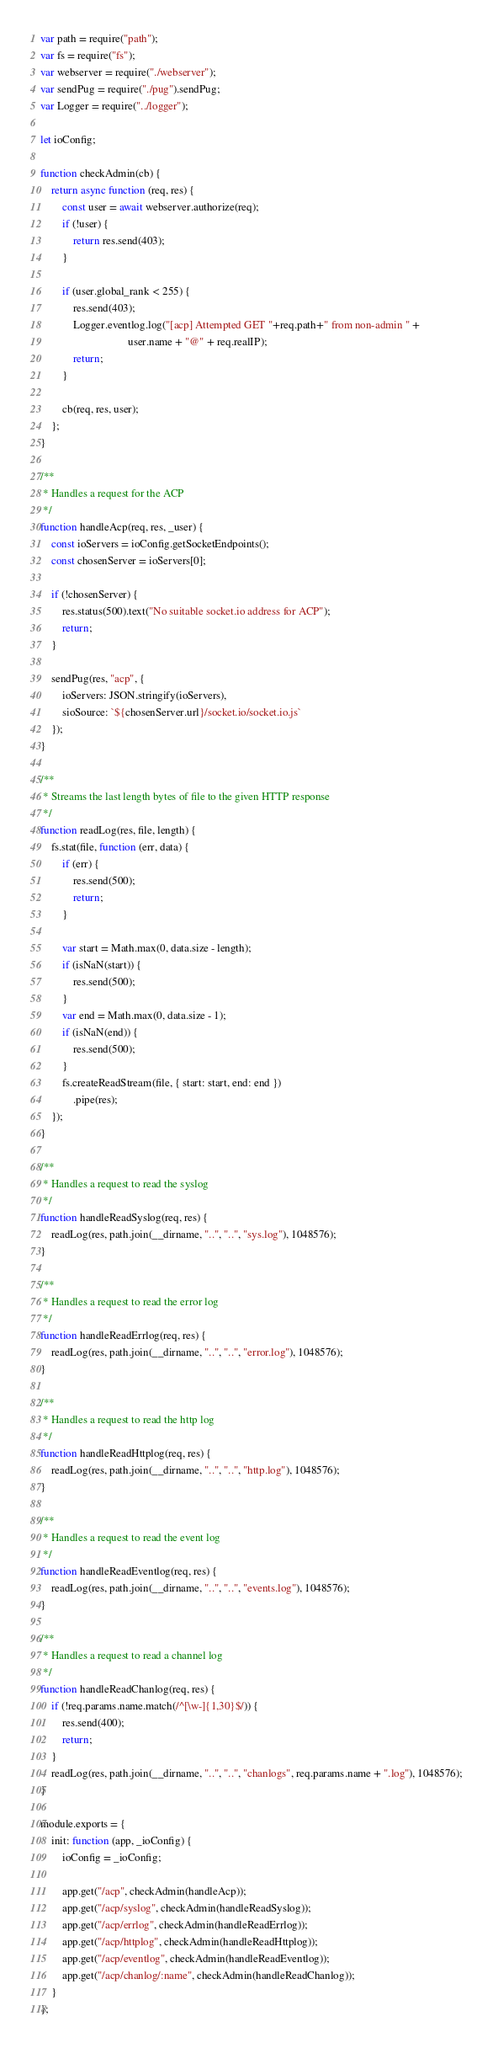<code> <loc_0><loc_0><loc_500><loc_500><_JavaScript_>var path = require("path");
var fs = require("fs");
var webserver = require("./webserver");
var sendPug = require("./pug").sendPug;
var Logger = require("../logger");

let ioConfig;

function checkAdmin(cb) {
    return async function (req, res) {
        const user = await webserver.authorize(req);
        if (!user) {
            return res.send(403);
        }

        if (user.global_rank < 255) {
            res.send(403);
            Logger.eventlog.log("[acp] Attempted GET "+req.path+" from non-admin " +
                                user.name + "@" + req.realIP);
            return;
        }

        cb(req, res, user);
    };
}

/**
 * Handles a request for the ACP
 */
function handleAcp(req, res, _user) {
    const ioServers = ioConfig.getSocketEndpoints();
    const chosenServer = ioServers[0];

    if (!chosenServer) {
        res.status(500).text("No suitable socket.io address for ACP");
        return;
    }

    sendPug(res, "acp", {
        ioServers: JSON.stringify(ioServers),
        sioSource: `${chosenServer.url}/socket.io/socket.io.js`
    });
}

/**
 * Streams the last length bytes of file to the given HTTP response
 */
function readLog(res, file, length) {
    fs.stat(file, function (err, data) {
        if (err) {
            res.send(500);
            return;
        }

        var start = Math.max(0, data.size - length);
        if (isNaN(start)) {
            res.send(500);
        }
        var end = Math.max(0, data.size - 1);
        if (isNaN(end)) {
            res.send(500);
        }
        fs.createReadStream(file, { start: start, end: end })
            .pipe(res);
    });
}

/**
 * Handles a request to read the syslog
 */
function handleReadSyslog(req, res) {
    readLog(res, path.join(__dirname, "..", "..", "sys.log"), 1048576);
}

/**
 * Handles a request to read the error log
 */
function handleReadErrlog(req, res) {
    readLog(res, path.join(__dirname, "..", "..", "error.log"), 1048576);
}

/**
 * Handles a request to read the http log
 */
function handleReadHttplog(req, res) {
    readLog(res, path.join(__dirname, "..", "..", "http.log"), 1048576);
}

/**
 * Handles a request to read the event log
 */
function handleReadEventlog(req, res) {
    readLog(res, path.join(__dirname, "..", "..", "events.log"), 1048576);
}

/**
 * Handles a request to read a channel log
 */
function handleReadChanlog(req, res) {
    if (!req.params.name.match(/^[\w-]{1,30}$/)) {
        res.send(400);
        return;
    }
    readLog(res, path.join(__dirname, "..", "..", "chanlogs", req.params.name + ".log"), 1048576);
}

module.exports = {
    init: function (app, _ioConfig) {
        ioConfig = _ioConfig;

        app.get("/acp", checkAdmin(handleAcp));
        app.get("/acp/syslog", checkAdmin(handleReadSyslog));
        app.get("/acp/errlog", checkAdmin(handleReadErrlog));
        app.get("/acp/httplog", checkAdmin(handleReadHttplog));
        app.get("/acp/eventlog", checkAdmin(handleReadEventlog));
        app.get("/acp/chanlog/:name", checkAdmin(handleReadChanlog));
    }
};
</code> 